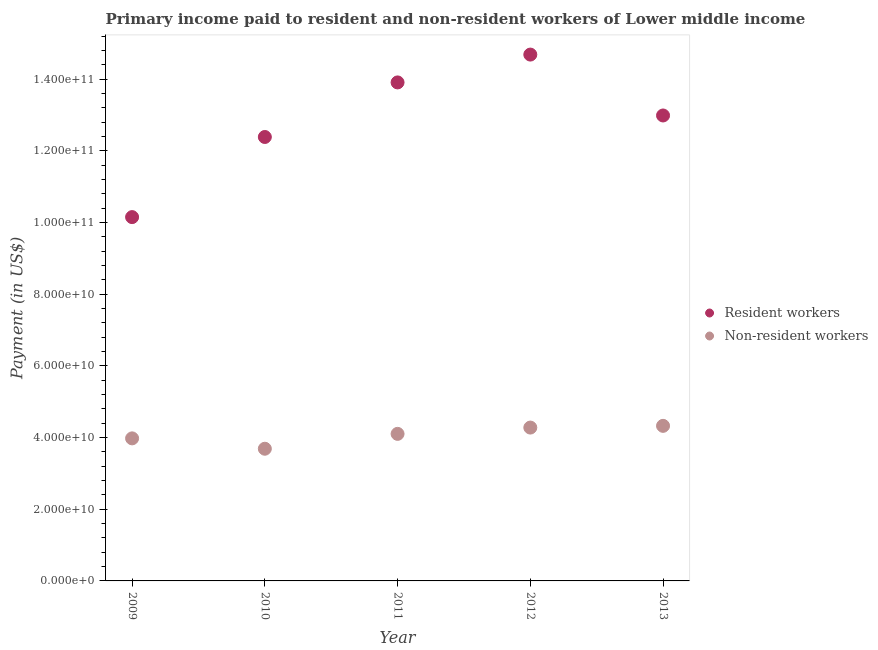How many different coloured dotlines are there?
Provide a short and direct response. 2. What is the payment made to resident workers in 2009?
Provide a succinct answer. 1.01e+11. Across all years, what is the maximum payment made to non-resident workers?
Ensure brevity in your answer.  4.33e+1. Across all years, what is the minimum payment made to resident workers?
Your response must be concise. 1.01e+11. What is the total payment made to resident workers in the graph?
Your answer should be compact. 6.41e+11. What is the difference between the payment made to non-resident workers in 2009 and that in 2012?
Offer a very short reply. -3.01e+09. What is the difference between the payment made to non-resident workers in 2011 and the payment made to resident workers in 2012?
Give a very brief answer. -1.06e+11. What is the average payment made to resident workers per year?
Ensure brevity in your answer.  1.28e+11. In the year 2010, what is the difference between the payment made to non-resident workers and payment made to resident workers?
Ensure brevity in your answer.  -8.70e+1. What is the ratio of the payment made to non-resident workers in 2009 to that in 2011?
Keep it short and to the point. 0.97. Is the payment made to resident workers in 2009 less than that in 2013?
Make the answer very short. Yes. What is the difference between the highest and the second highest payment made to non-resident workers?
Ensure brevity in your answer.  4.80e+08. What is the difference between the highest and the lowest payment made to resident workers?
Make the answer very short. 4.53e+1. In how many years, is the payment made to resident workers greater than the average payment made to resident workers taken over all years?
Make the answer very short. 3. Is the sum of the payment made to resident workers in 2010 and 2011 greater than the maximum payment made to non-resident workers across all years?
Your response must be concise. Yes. Does the payment made to resident workers monotonically increase over the years?
Your answer should be compact. No. Is the payment made to resident workers strictly greater than the payment made to non-resident workers over the years?
Give a very brief answer. Yes. Is the payment made to non-resident workers strictly less than the payment made to resident workers over the years?
Provide a short and direct response. Yes. How many dotlines are there?
Your answer should be compact. 2. What is the difference between two consecutive major ticks on the Y-axis?
Offer a very short reply. 2.00e+1. How are the legend labels stacked?
Your answer should be compact. Vertical. What is the title of the graph?
Provide a short and direct response. Primary income paid to resident and non-resident workers of Lower middle income. Does "Frequency of shipment arrival" appear as one of the legend labels in the graph?
Offer a terse response. No. What is the label or title of the Y-axis?
Make the answer very short. Payment (in US$). What is the Payment (in US$) of Resident workers in 2009?
Offer a terse response. 1.01e+11. What is the Payment (in US$) in Non-resident workers in 2009?
Offer a very short reply. 3.98e+1. What is the Payment (in US$) in Resident workers in 2010?
Provide a short and direct response. 1.24e+11. What is the Payment (in US$) in Non-resident workers in 2010?
Offer a very short reply. 3.69e+1. What is the Payment (in US$) in Resident workers in 2011?
Give a very brief answer. 1.39e+11. What is the Payment (in US$) of Non-resident workers in 2011?
Keep it short and to the point. 4.10e+1. What is the Payment (in US$) in Resident workers in 2012?
Keep it short and to the point. 1.47e+11. What is the Payment (in US$) in Non-resident workers in 2012?
Provide a succinct answer. 4.28e+1. What is the Payment (in US$) of Resident workers in 2013?
Provide a succinct answer. 1.30e+11. What is the Payment (in US$) in Non-resident workers in 2013?
Make the answer very short. 4.33e+1. Across all years, what is the maximum Payment (in US$) of Resident workers?
Give a very brief answer. 1.47e+11. Across all years, what is the maximum Payment (in US$) of Non-resident workers?
Your answer should be compact. 4.33e+1. Across all years, what is the minimum Payment (in US$) in Resident workers?
Make the answer very short. 1.01e+11. Across all years, what is the minimum Payment (in US$) in Non-resident workers?
Make the answer very short. 3.69e+1. What is the total Payment (in US$) of Resident workers in the graph?
Provide a succinct answer. 6.41e+11. What is the total Payment (in US$) in Non-resident workers in the graph?
Offer a very short reply. 2.04e+11. What is the difference between the Payment (in US$) of Resident workers in 2009 and that in 2010?
Your answer should be compact. -2.24e+1. What is the difference between the Payment (in US$) of Non-resident workers in 2009 and that in 2010?
Ensure brevity in your answer.  2.89e+09. What is the difference between the Payment (in US$) of Resident workers in 2009 and that in 2011?
Give a very brief answer. -3.76e+1. What is the difference between the Payment (in US$) in Non-resident workers in 2009 and that in 2011?
Offer a terse response. -1.26e+09. What is the difference between the Payment (in US$) of Resident workers in 2009 and that in 2012?
Make the answer very short. -4.53e+1. What is the difference between the Payment (in US$) in Non-resident workers in 2009 and that in 2012?
Provide a short and direct response. -3.01e+09. What is the difference between the Payment (in US$) of Resident workers in 2009 and that in 2013?
Make the answer very short. -2.84e+1. What is the difference between the Payment (in US$) in Non-resident workers in 2009 and that in 2013?
Provide a short and direct response. -3.49e+09. What is the difference between the Payment (in US$) in Resident workers in 2010 and that in 2011?
Offer a terse response. -1.52e+1. What is the difference between the Payment (in US$) of Non-resident workers in 2010 and that in 2011?
Offer a very short reply. -4.15e+09. What is the difference between the Payment (in US$) in Resident workers in 2010 and that in 2012?
Your answer should be compact. -2.30e+1. What is the difference between the Payment (in US$) of Non-resident workers in 2010 and that in 2012?
Keep it short and to the point. -5.90e+09. What is the difference between the Payment (in US$) in Resident workers in 2010 and that in 2013?
Offer a terse response. -6.00e+09. What is the difference between the Payment (in US$) in Non-resident workers in 2010 and that in 2013?
Offer a terse response. -6.38e+09. What is the difference between the Payment (in US$) in Resident workers in 2011 and that in 2012?
Your answer should be very brief. -7.77e+09. What is the difference between the Payment (in US$) of Non-resident workers in 2011 and that in 2012?
Make the answer very short. -1.75e+09. What is the difference between the Payment (in US$) in Resident workers in 2011 and that in 2013?
Keep it short and to the point. 9.22e+09. What is the difference between the Payment (in US$) in Non-resident workers in 2011 and that in 2013?
Your answer should be compact. -2.23e+09. What is the difference between the Payment (in US$) in Resident workers in 2012 and that in 2013?
Your answer should be very brief. 1.70e+1. What is the difference between the Payment (in US$) in Non-resident workers in 2012 and that in 2013?
Give a very brief answer. -4.80e+08. What is the difference between the Payment (in US$) in Resident workers in 2009 and the Payment (in US$) in Non-resident workers in 2010?
Give a very brief answer. 6.46e+1. What is the difference between the Payment (in US$) of Resident workers in 2009 and the Payment (in US$) of Non-resident workers in 2011?
Offer a terse response. 6.05e+1. What is the difference between the Payment (in US$) in Resident workers in 2009 and the Payment (in US$) in Non-resident workers in 2012?
Keep it short and to the point. 5.87e+1. What is the difference between the Payment (in US$) in Resident workers in 2009 and the Payment (in US$) in Non-resident workers in 2013?
Keep it short and to the point. 5.82e+1. What is the difference between the Payment (in US$) of Resident workers in 2010 and the Payment (in US$) of Non-resident workers in 2011?
Offer a terse response. 8.28e+1. What is the difference between the Payment (in US$) in Resident workers in 2010 and the Payment (in US$) in Non-resident workers in 2012?
Provide a succinct answer. 8.11e+1. What is the difference between the Payment (in US$) in Resident workers in 2010 and the Payment (in US$) in Non-resident workers in 2013?
Keep it short and to the point. 8.06e+1. What is the difference between the Payment (in US$) of Resident workers in 2011 and the Payment (in US$) of Non-resident workers in 2012?
Provide a succinct answer. 9.63e+1. What is the difference between the Payment (in US$) in Resident workers in 2011 and the Payment (in US$) in Non-resident workers in 2013?
Make the answer very short. 9.58e+1. What is the difference between the Payment (in US$) of Resident workers in 2012 and the Payment (in US$) of Non-resident workers in 2013?
Make the answer very short. 1.04e+11. What is the average Payment (in US$) of Resident workers per year?
Your answer should be compact. 1.28e+11. What is the average Payment (in US$) in Non-resident workers per year?
Provide a succinct answer. 4.07e+1. In the year 2009, what is the difference between the Payment (in US$) in Resident workers and Payment (in US$) in Non-resident workers?
Provide a succinct answer. 6.17e+1. In the year 2010, what is the difference between the Payment (in US$) in Resident workers and Payment (in US$) in Non-resident workers?
Offer a very short reply. 8.70e+1. In the year 2011, what is the difference between the Payment (in US$) in Resident workers and Payment (in US$) in Non-resident workers?
Your answer should be compact. 9.80e+1. In the year 2012, what is the difference between the Payment (in US$) in Resident workers and Payment (in US$) in Non-resident workers?
Provide a succinct answer. 1.04e+11. In the year 2013, what is the difference between the Payment (in US$) in Resident workers and Payment (in US$) in Non-resident workers?
Your answer should be very brief. 8.66e+1. What is the ratio of the Payment (in US$) of Resident workers in 2009 to that in 2010?
Offer a terse response. 0.82. What is the ratio of the Payment (in US$) in Non-resident workers in 2009 to that in 2010?
Give a very brief answer. 1.08. What is the ratio of the Payment (in US$) of Resident workers in 2009 to that in 2011?
Your response must be concise. 0.73. What is the ratio of the Payment (in US$) in Non-resident workers in 2009 to that in 2011?
Give a very brief answer. 0.97. What is the ratio of the Payment (in US$) of Resident workers in 2009 to that in 2012?
Provide a succinct answer. 0.69. What is the ratio of the Payment (in US$) in Non-resident workers in 2009 to that in 2012?
Offer a terse response. 0.93. What is the ratio of the Payment (in US$) of Resident workers in 2009 to that in 2013?
Give a very brief answer. 0.78. What is the ratio of the Payment (in US$) in Non-resident workers in 2009 to that in 2013?
Ensure brevity in your answer.  0.92. What is the ratio of the Payment (in US$) of Resident workers in 2010 to that in 2011?
Make the answer very short. 0.89. What is the ratio of the Payment (in US$) of Non-resident workers in 2010 to that in 2011?
Ensure brevity in your answer.  0.9. What is the ratio of the Payment (in US$) of Resident workers in 2010 to that in 2012?
Keep it short and to the point. 0.84. What is the ratio of the Payment (in US$) in Non-resident workers in 2010 to that in 2012?
Provide a short and direct response. 0.86. What is the ratio of the Payment (in US$) in Resident workers in 2010 to that in 2013?
Offer a terse response. 0.95. What is the ratio of the Payment (in US$) in Non-resident workers in 2010 to that in 2013?
Your answer should be compact. 0.85. What is the ratio of the Payment (in US$) in Resident workers in 2011 to that in 2012?
Your answer should be compact. 0.95. What is the ratio of the Payment (in US$) of Resident workers in 2011 to that in 2013?
Ensure brevity in your answer.  1.07. What is the ratio of the Payment (in US$) in Non-resident workers in 2011 to that in 2013?
Your answer should be very brief. 0.95. What is the ratio of the Payment (in US$) in Resident workers in 2012 to that in 2013?
Your answer should be compact. 1.13. What is the ratio of the Payment (in US$) in Non-resident workers in 2012 to that in 2013?
Your answer should be compact. 0.99. What is the difference between the highest and the second highest Payment (in US$) of Resident workers?
Offer a terse response. 7.77e+09. What is the difference between the highest and the second highest Payment (in US$) in Non-resident workers?
Your answer should be compact. 4.80e+08. What is the difference between the highest and the lowest Payment (in US$) in Resident workers?
Offer a very short reply. 4.53e+1. What is the difference between the highest and the lowest Payment (in US$) of Non-resident workers?
Your answer should be very brief. 6.38e+09. 